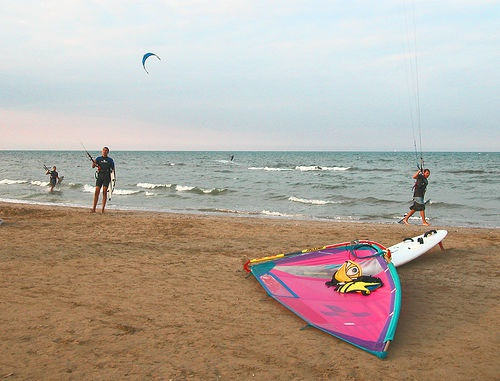Describe the objects in this image and their specific colors. I can see kite in white, violet, purple, salmon, and brown tones, people in white, black, maroon, and gray tones, surfboard in white, black, darkgray, and gray tones, and kite in white, teal, darkgray, lightgray, and blue tones in this image. 